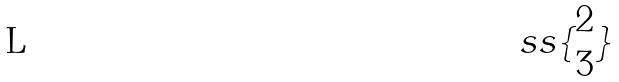<formula> <loc_0><loc_0><loc_500><loc_500>s s \{ \begin{matrix} 2 \\ 3 \end{matrix} \}</formula> 